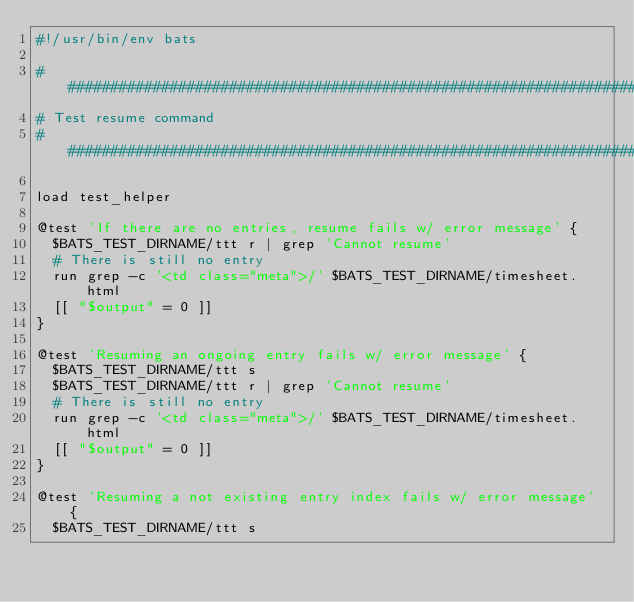<code> <loc_0><loc_0><loc_500><loc_500><_Bash_>#!/usr/bin/env bats

########################################################################################################################
# Test resume command
########################################################################################################################

load test_helper

@test 'If there are no entries, resume fails w/ error message' {
  $BATS_TEST_DIRNAME/ttt r | grep 'Cannot resume'
  # There is still no entry
  run grep -c '<td class="meta">/' $BATS_TEST_DIRNAME/timesheet.html
  [[ "$output" = 0 ]]
}

@test 'Resuming an ongoing entry fails w/ error message' {
  $BATS_TEST_DIRNAME/ttt s
  $BATS_TEST_DIRNAME/ttt r | grep 'Cannot resume'
  # There is still no entry
  run grep -c '<td class="meta">/' $BATS_TEST_DIRNAME/timesheet.html
  [[ "$output" = 0 ]]
}

@test 'Resuming a not existing entry index fails w/ error message' {
  $BATS_TEST_DIRNAME/ttt s</code> 